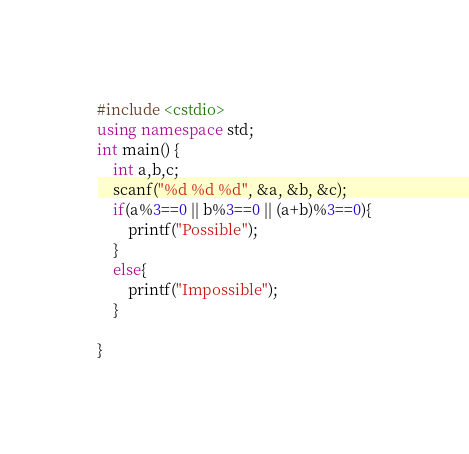Convert code to text. <code><loc_0><loc_0><loc_500><loc_500><_C++_>
#include <cstdio>  
using namespace std;  
int main() { 	
	int a,b,c; 	
	scanf("%d %d %d", &a, &b, &c); 	
	if(a%3==0 || b%3==0 || (a+b)%3==0){
		printf("Possible");
	}
	else{
		printf("Impossible");
	}
	
} </code> 